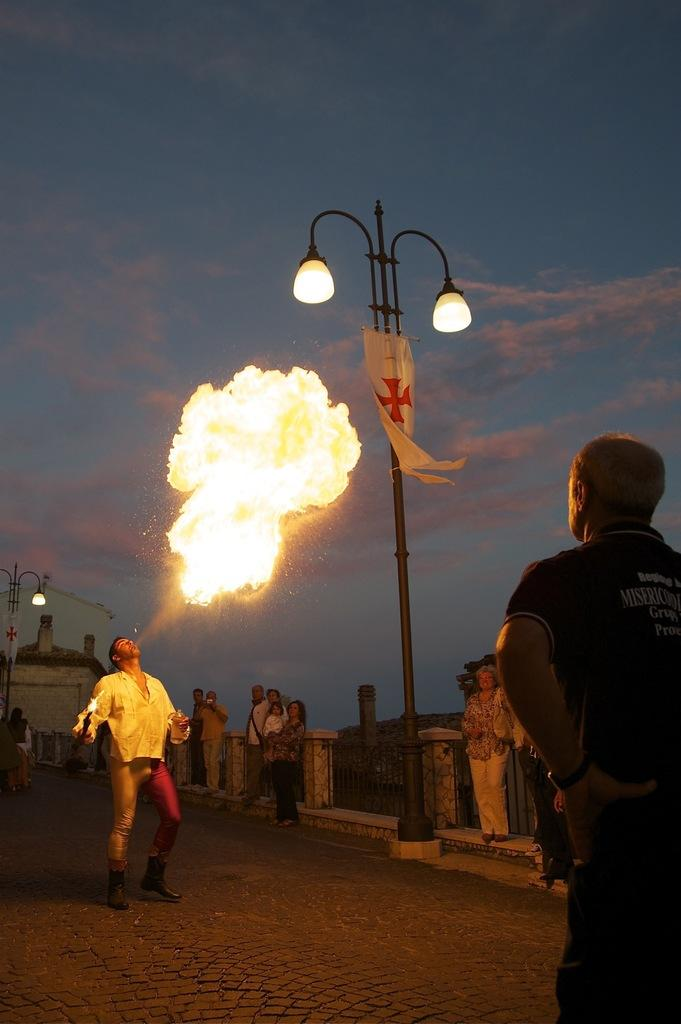Who or what can be seen in the image? There are people in the image. What is present in the image that might be used for support or safety? There is railing in the image. What structures are visible in the image that provide light? There are light poles in the image. What symbol or emblem can be seen in the image? There is a flag in the image. What is the source of heat or light in the image? There is fire in the image. What type of man-made structure is visible in the image? There is a building in the image. What is the condition of the sky in the image? The sky is cloudy in the image. How many snails can be seen crawling on the building in the image? There are no snails visible in the image; the focus is on the people, railing, light poles, flag, fire, and building. 